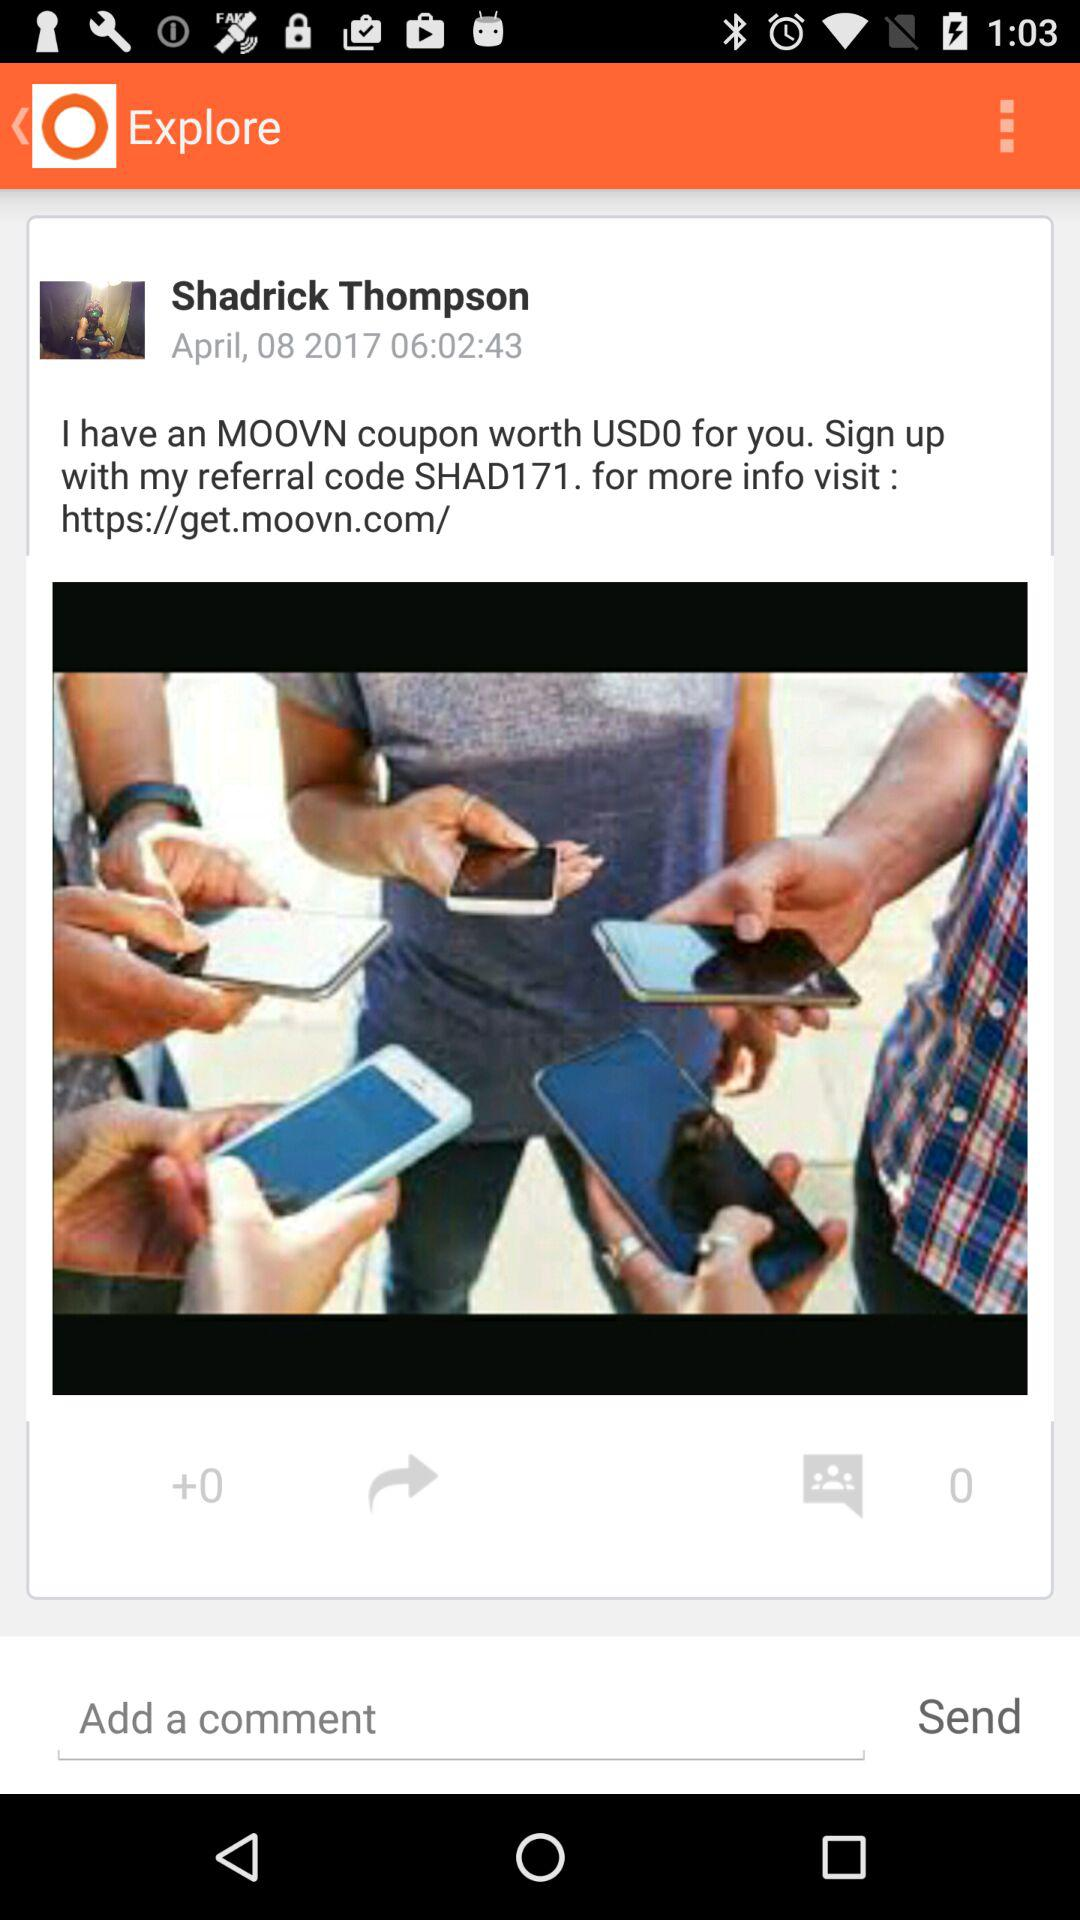What is the referral code? The referral code is SHAD171. 